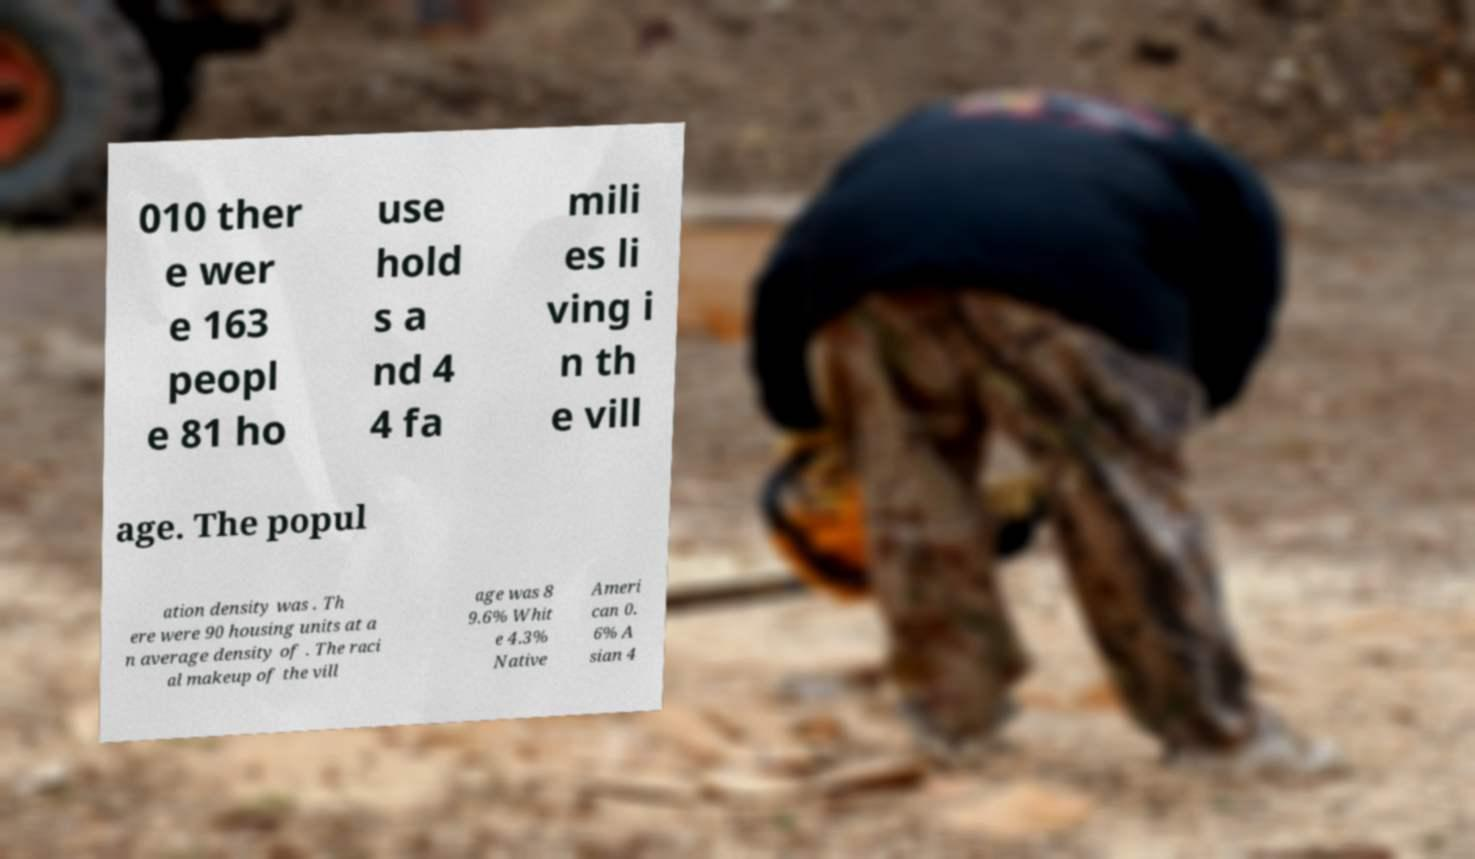What messages or text are displayed in this image? I need them in a readable, typed format. 010 ther e wer e 163 peopl e 81 ho use hold s a nd 4 4 fa mili es li ving i n th e vill age. The popul ation density was . Th ere were 90 housing units at a n average density of . The raci al makeup of the vill age was 8 9.6% Whit e 4.3% Native Ameri can 0. 6% A sian 4 